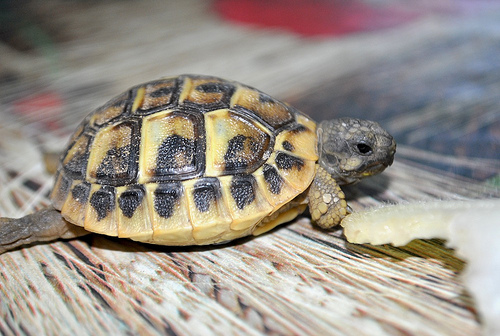<image>
Is the shell on the turtle? Yes. Looking at the image, I can see the shell is positioned on top of the turtle, with the turtle providing support. 